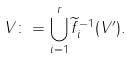<formula> <loc_0><loc_0><loc_500><loc_500>V \colon = \bigcup _ { i = 1 } ^ { r } \widetilde { f } _ { i } ^ { - 1 } ( V ^ { \prime } ) .</formula> 